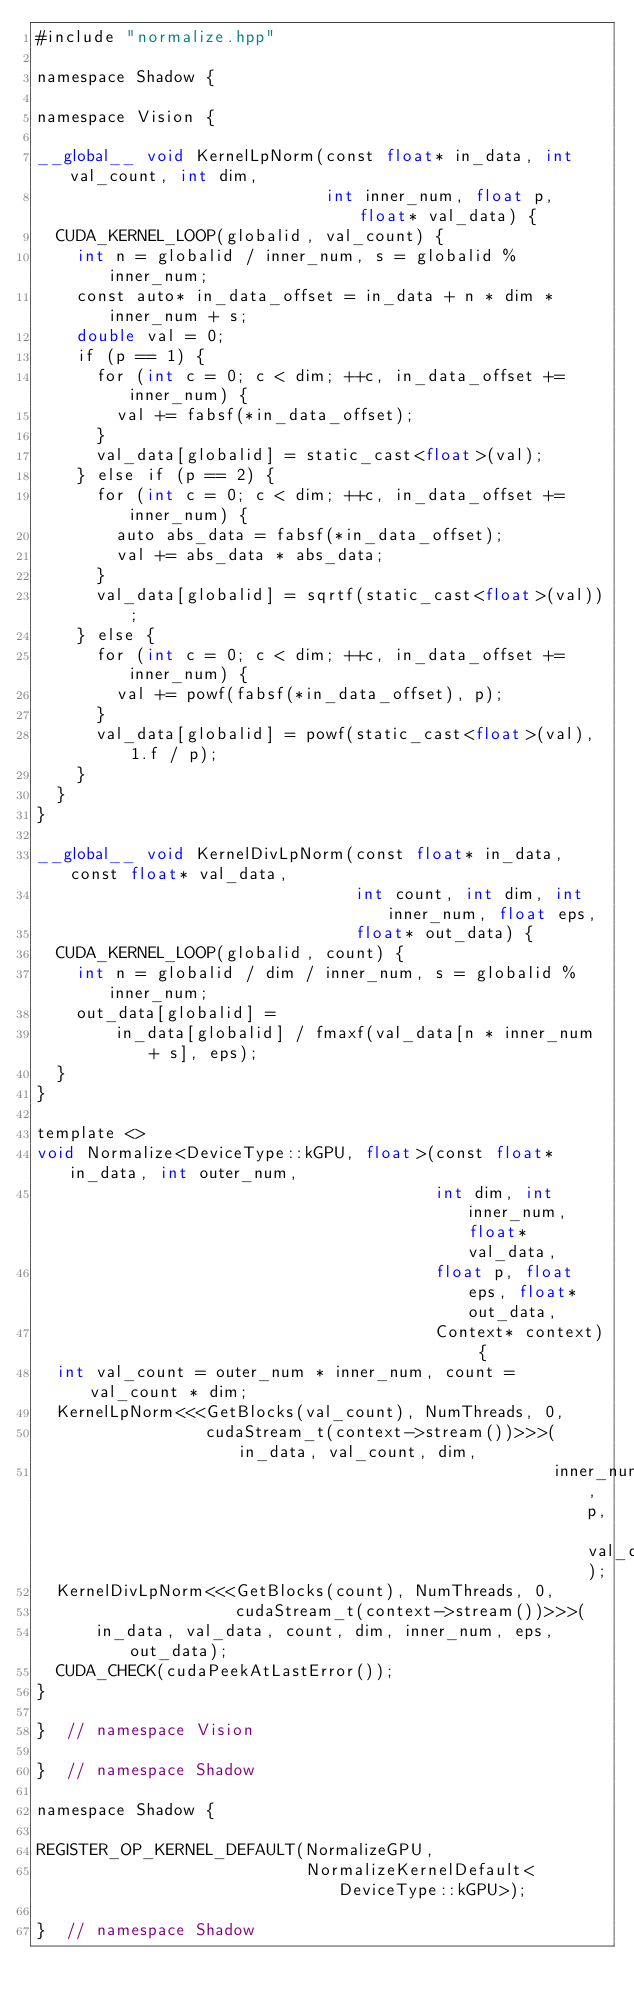Convert code to text. <code><loc_0><loc_0><loc_500><loc_500><_Cuda_>#include "normalize.hpp"

namespace Shadow {

namespace Vision {

__global__ void KernelLpNorm(const float* in_data, int val_count, int dim,
                             int inner_num, float p, float* val_data) {
  CUDA_KERNEL_LOOP(globalid, val_count) {
    int n = globalid / inner_num, s = globalid % inner_num;
    const auto* in_data_offset = in_data + n * dim * inner_num + s;
    double val = 0;
    if (p == 1) {
      for (int c = 0; c < dim; ++c, in_data_offset += inner_num) {
        val += fabsf(*in_data_offset);
      }
      val_data[globalid] = static_cast<float>(val);
    } else if (p == 2) {
      for (int c = 0; c < dim; ++c, in_data_offset += inner_num) {
        auto abs_data = fabsf(*in_data_offset);
        val += abs_data * abs_data;
      }
      val_data[globalid] = sqrtf(static_cast<float>(val));
    } else {
      for (int c = 0; c < dim; ++c, in_data_offset += inner_num) {
        val += powf(fabsf(*in_data_offset), p);
      }
      val_data[globalid] = powf(static_cast<float>(val), 1.f / p);
    }
  }
}

__global__ void KernelDivLpNorm(const float* in_data, const float* val_data,
                                int count, int dim, int inner_num, float eps,
                                float* out_data) {
  CUDA_KERNEL_LOOP(globalid, count) {
    int n = globalid / dim / inner_num, s = globalid % inner_num;
    out_data[globalid] =
        in_data[globalid] / fmaxf(val_data[n * inner_num + s], eps);
  }
}

template <>
void Normalize<DeviceType::kGPU, float>(const float* in_data, int outer_num,
                                        int dim, int inner_num, float* val_data,
                                        float p, float eps, float* out_data,
                                        Context* context) {
  int val_count = outer_num * inner_num, count = val_count * dim;
  KernelLpNorm<<<GetBlocks(val_count), NumThreads, 0,
                 cudaStream_t(context->stream())>>>(in_data, val_count, dim,
                                                    inner_num, p, val_data);
  KernelDivLpNorm<<<GetBlocks(count), NumThreads, 0,
                    cudaStream_t(context->stream())>>>(
      in_data, val_data, count, dim, inner_num, eps, out_data);
  CUDA_CHECK(cudaPeekAtLastError());
}

}  // namespace Vision

}  // namespace Shadow

namespace Shadow {

REGISTER_OP_KERNEL_DEFAULT(NormalizeGPU,
                           NormalizeKernelDefault<DeviceType::kGPU>);

}  // namespace Shadow
</code> 